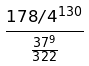<formula> <loc_0><loc_0><loc_500><loc_500>\frac { 1 7 8 / 4 ^ { 1 3 0 } } { \frac { 3 7 ^ { 9 } } { 3 2 2 } }</formula> 